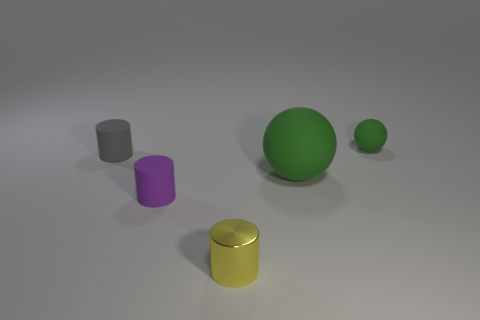Add 1 big cyan rubber things. How many objects exist? 6 Subtract all spheres. How many objects are left? 3 Subtract 0 brown cubes. How many objects are left? 5 Subtract all big brown metallic objects. Subtract all purple rubber cylinders. How many objects are left? 4 Add 2 big green matte balls. How many big green matte balls are left? 3 Add 5 small things. How many small things exist? 9 